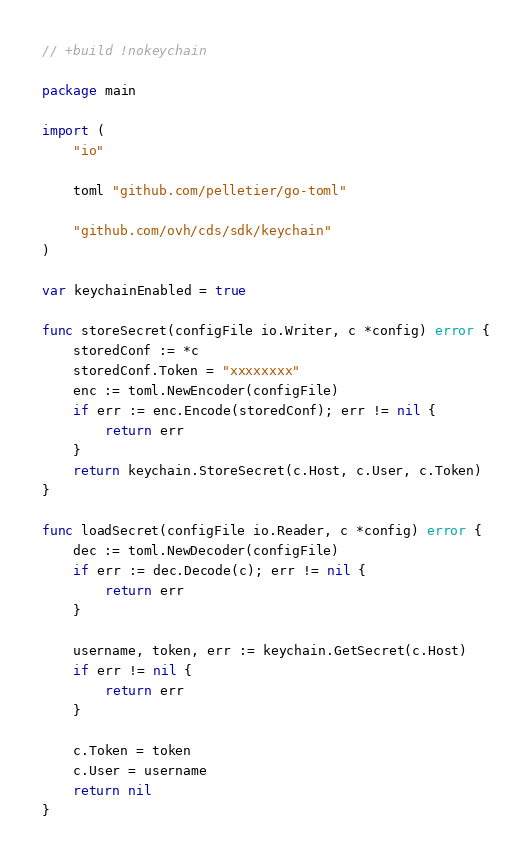<code> <loc_0><loc_0><loc_500><loc_500><_Go_>// +build !nokeychain

package main

import (
	"io"

	toml "github.com/pelletier/go-toml"

	"github.com/ovh/cds/sdk/keychain"
)

var keychainEnabled = true

func storeSecret(configFile io.Writer, c *config) error {
	storedConf := *c
	storedConf.Token = "xxxxxxxx"
	enc := toml.NewEncoder(configFile)
	if err := enc.Encode(storedConf); err != nil {
		return err
	}
	return keychain.StoreSecret(c.Host, c.User, c.Token)
}

func loadSecret(configFile io.Reader, c *config) error {
	dec := toml.NewDecoder(configFile)
	if err := dec.Decode(c); err != nil {
		return err
	}

	username, token, err := keychain.GetSecret(c.Host)
	if err != nil {
		return err
	}

	c.Token = token
	c.User = username
	return nil
}
</code> 